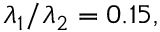<formula> <loc_0><loc_0><loc_500><loc_500>\lambda _ { 1 } / \lambda _ { 2 } = 0 . 1 5 ,</formula> 